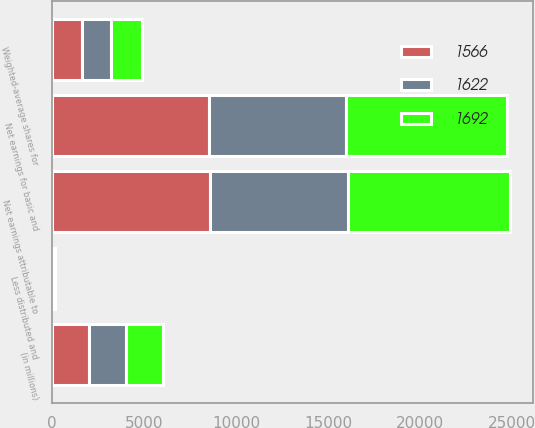<chart> <loc_0><loc_0><loc_500><loc_500><stacked_bar_chart><ecel><fcel>(in millions)<fcel>Net earnings attributable to<fcel>Less distributed and<fcel>Net earnings for basic and<fcel>Weighted-average shares for<nl><fcel>1622<fcel>2014<fcel>7493<fcel>34<fcel>7459<fcel>1566<nl><fcel>1566<fcel>2013<fcel>8576<fcel>45<fcel>8531<fcel>1622<nl><fcel>1692<fcel>2012<fcel>8800<fcel>48<fcel>8752<fcel>1692<nl></chart> 